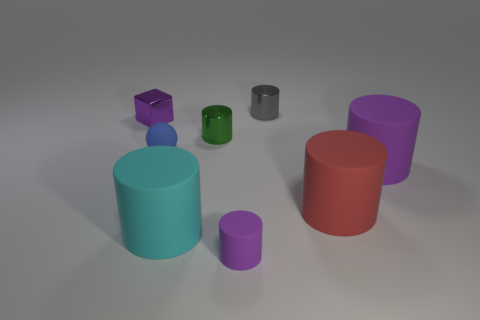Subtract 3 cylinders. How many cylinders are left? 3 Subtract all gray cylinders. How many cylinders are left? 5 Subtract all green cylinders. How many cylinders are left? 5 Subtract all green cylinders. Subtract all blue cubes. How many cylinders are left? 5 Add 2 tiny purple metal cubes. How many objects exist? 10 Subtract all cubes. How many objects are left? 7 Subtract all blue rubber objects. Subtract all blue balls. How many objects are left? 6 Add 7 large cyan rubber objects. How many large cyan rubber objects are left? 8 Add 4 tiny purple balls. How many tiny purple balls exist? 4 Subtract 0 gray cubes. How many objects are left? 8 